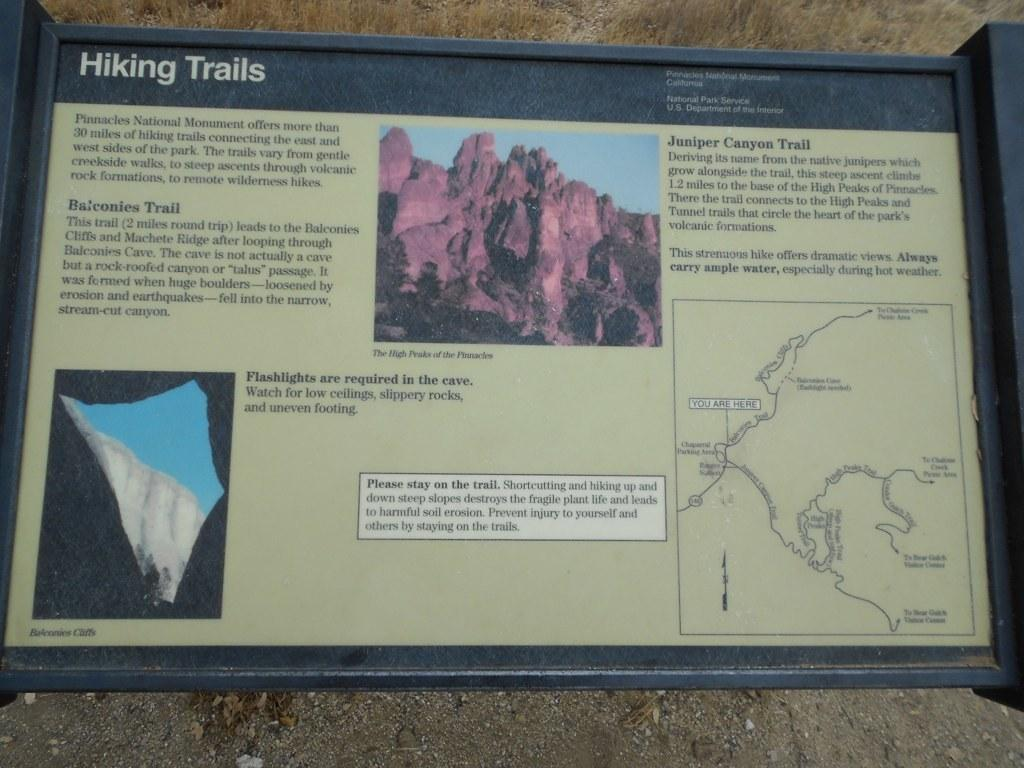<image>
Present a compact description of the photo's key features. A sign shows the hiking trails in the areas. 